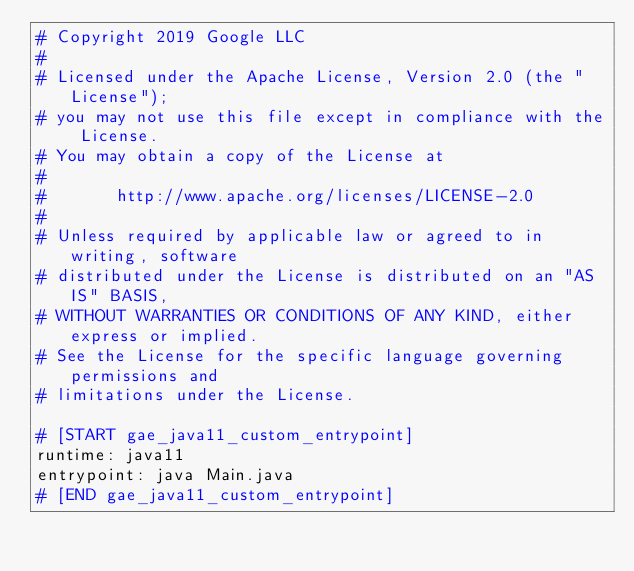<code> <loc_0><loc_0><loc_500><loc_500><_YAML_># Copyright 2019 Google LLC
#
# Licensed under the Apache License, Version 2.0 (the "License");
# you may not use this file except in compliance with the License.
# You may obtain a copy of the License at
#
#       http://www.apache.org/licenses/LICENSE-2.0
#
# Unless required by applicable law or agreed to in writing, software
# distributed under the License is distributed on an "AS IS" BASIS,
# WITHOUT WARRANTIES OR CONDITIONS OF ANY KIND, either express or implied.
# See the License for the specific language governing permissions and
# limitations under the License.

# [START gae_java11_custom_entrypoint]
runtime: java11
entrypoint: java Main.java
# [END gae_java11_custom_entrypoint]
</code> 